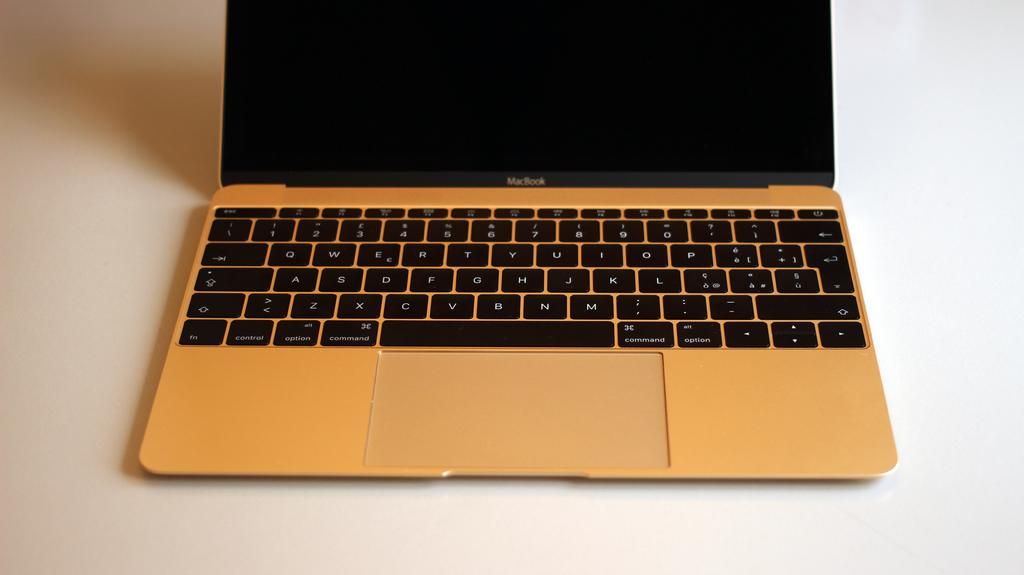What brand of computer is on the table?
Make the answer very short. Macbook. What button is to the right of the control button?
Offer a terse response. Option. 